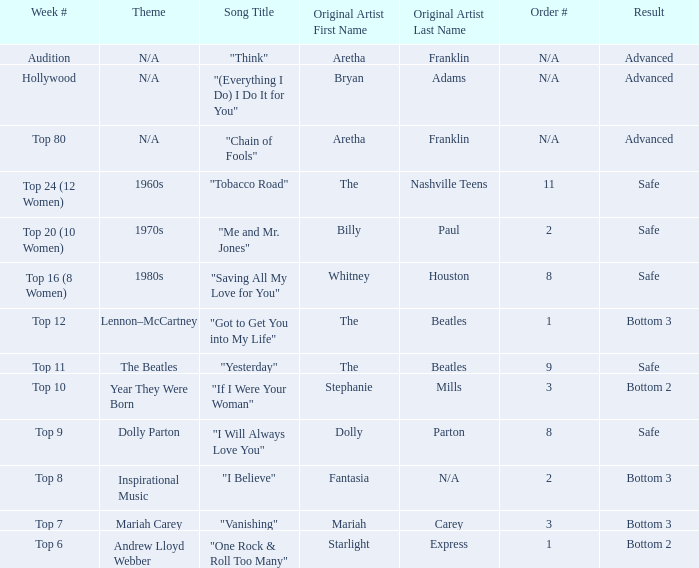Name the order number for the beatles and result is safe 9.0. 